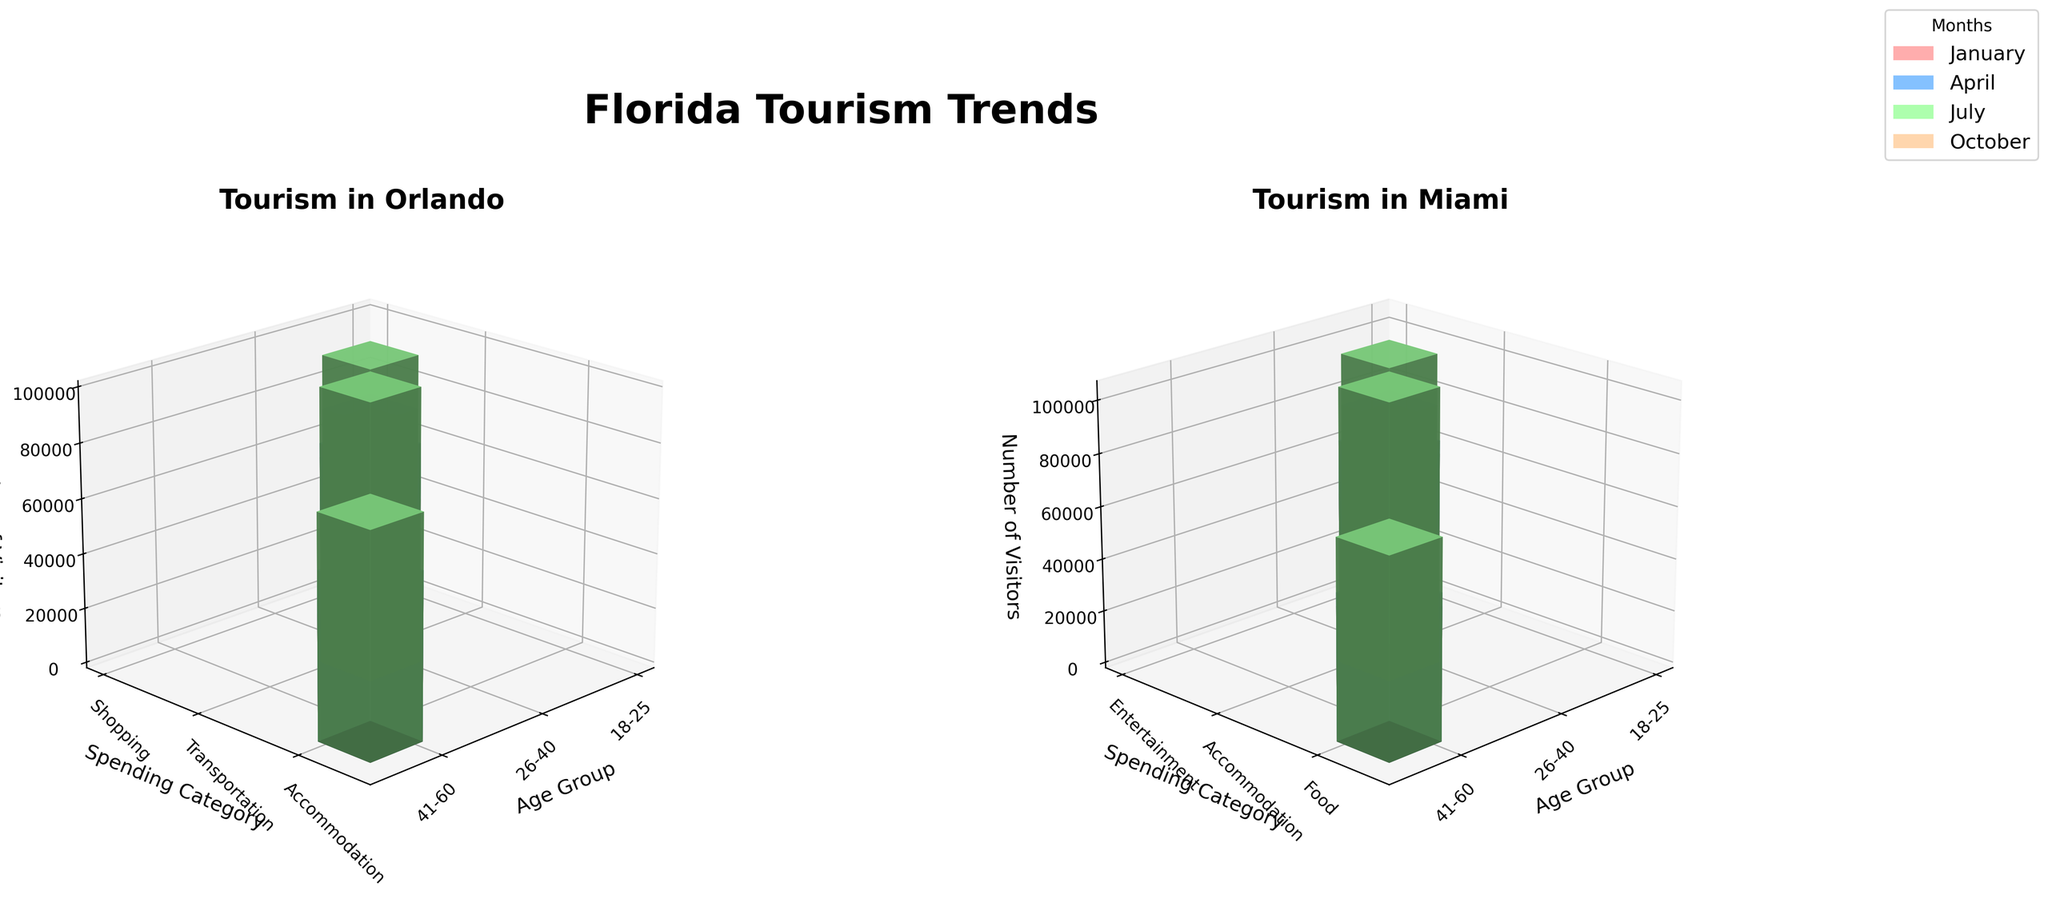What's the title of the figure? The title of the figure is located at the top center of the image.
Answer: Florida Tourism Trends What's the label for the x-axis in the subplot for Orlando? The x-axis label is shown at the bottom-left corner in each subplot. Look at the subplot for Orlando and find the x-axis label.
Answer: Age Group Which city has the highest number of visitors in July from the 26-40 age group for the Food spending category? To answer this, check the height of bars associated with the 26-40 age group and Food spending category in the July section of Orlando and Miami subplots.
Answer: Miami Which age group had the most visitors in April for Orlando? Look at the bars for each age group in the subplot for Orlando during April. Determine which bar is tallest.
Answer: 26-40 What is the difference in visitor numbers in January for the 18-25 age group between Orlando and Miami? Find the height of bars representing the 18-25 age group in January for both cities. Subtract the height of Miami's bar from Orlando's.
Answer: -5000 In which month did Miami see the highest number of visitors for the Entertainment spending category? Check the Miami subplot and compare the heights of bars related to Entertainment spending in each month to determine which is highest.
Answer: April What's the spending category with the highest average spending in Orlando in July? Identify the bars for each spending category in Orlando during July and determine which is highest by evaluating the corresponding z-axis labels for average spending.
Answer: Accommodation Compare the number of visitors for the 41-60 age group in the Accommodation spending category in Miami for January and October. Which month had more visitors? Check the heights of the bars for the 41-60 age group and Accommodation spending category in Miami for January and October. Compare the heights.
Answer: January Considering all months and categories, which city had more visitors in the 18-25 age group overall? Sum up the heights of the bars within the 18-25 age group in both the Orlando and Miami subplots across all months to compare the total.
Answer: Miami 